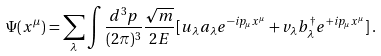<formula> <loc_0><loc_0><loc_500><loc_500>\Psi ( x ^ { \mu } ) = \sum _ { \lambda } \int \frac { d ^ { 3 } { p } } { ( 2 \pi ) ^ { 3 } } \frac { \sqrt { m } } { 2 E } [ u _ { \lambda } a _ { \lambda } e ^ { - i p _ { \mu } x ^ { \mu } } + v _ { \lambda } b ^ { \dagger } _ { \lambda } e ^ { + i p _ { \mu } x ^ { \mu } } ] \, .</formula> 